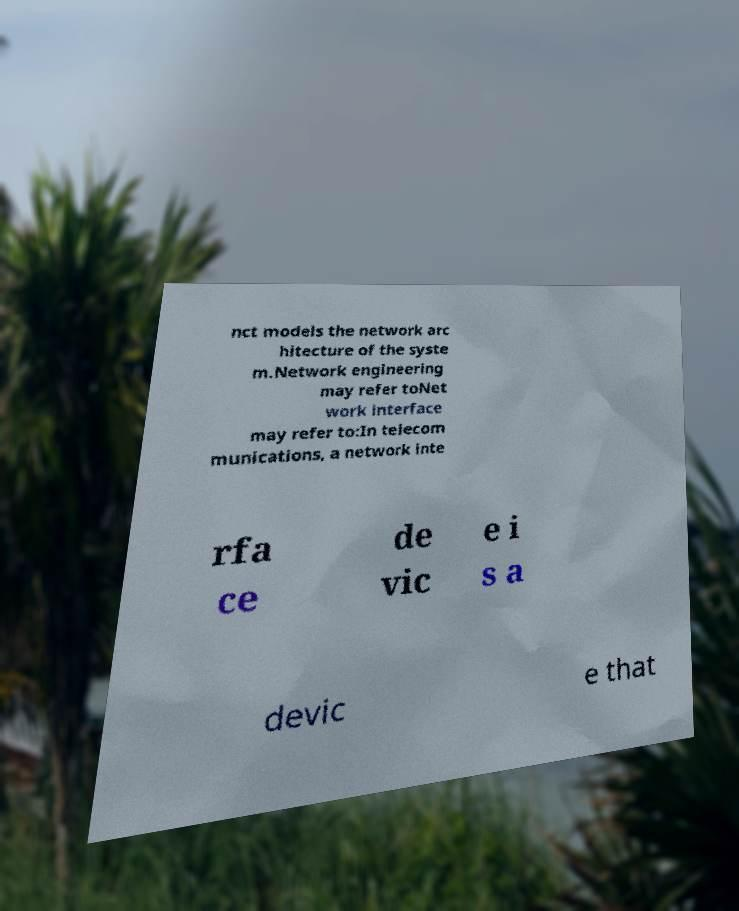Can you accurately transcribe the text from the provided image for me? nct models the network arc hitecture of the syste m.Network engineering may refer toNet work interface may refer to:In telecom munications, a network inte rfa ce de vic e i s a devic e that 